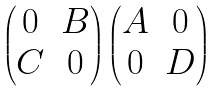Convert formula to latex. <formula><loc_0><loc_0><loc_500><loc_500>\begin{pmatrix} 0 & B \\ C & 0 \end{pmatrix} \begin{pmatrix} A & 0 \\ 0 & D \end{pmatrix}</formula> 